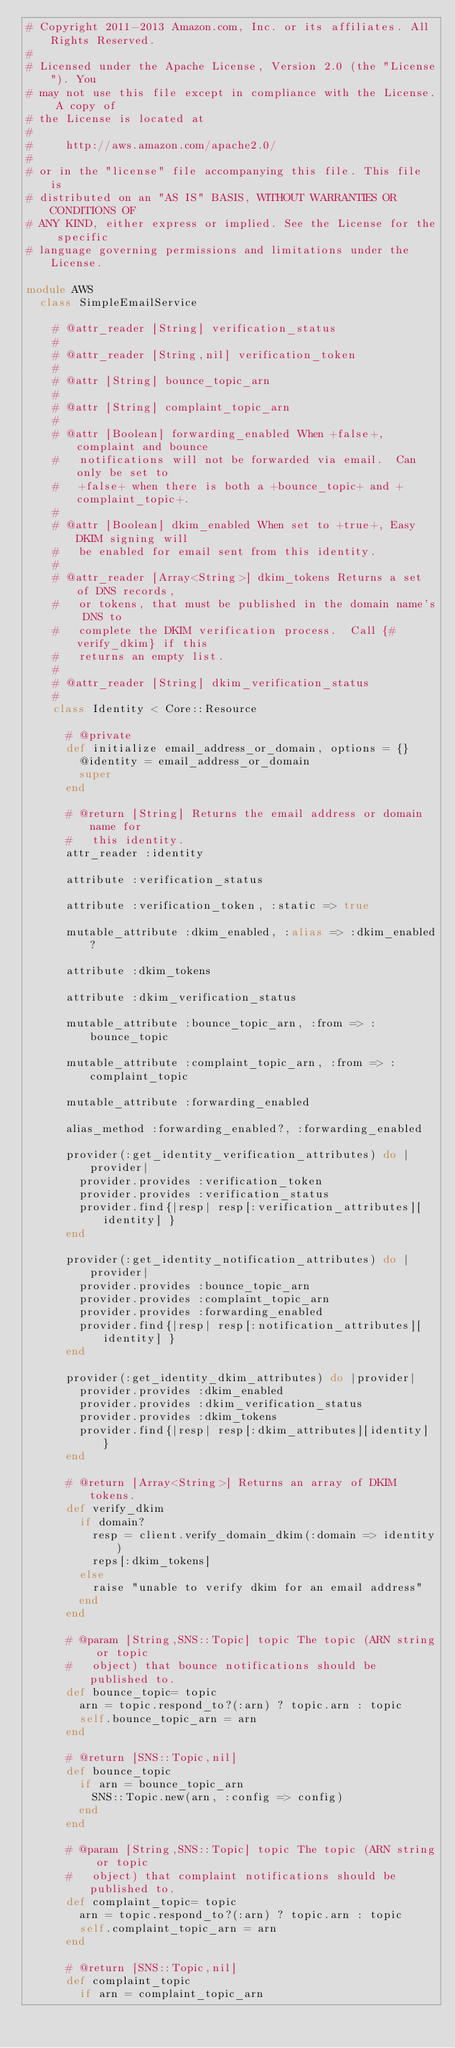<code> <loc_0><loc_0><loc_500><loc_500><_Ruby_># Copyright 2011-2013 Amazon.com, Inc. or its affiliates. All Rights Reserved.
#
# Licensed under the Apache License, Version 2.0 (the "License"). You
# may not use this file except in compliance with the License. A copy of
# the License is located at
#
#     http://aws.amazon.com/apache2.0/
#
# or in the "license" file accompanying this file. This file is
# distributed on an "AS IS" BASIS, WITHOUT WARRANTIES OR CONDITIONS OF
# ANY KIND, either express or implied. See the License for the specific
# language governing permissions and limitations under the License.

module AWS
  class SimpleEmailService

    # @attr_reader [String] verification_status
    #
    # @attr_reader [String,nil] verification_token
    #
    # @attr [String] bounce_topic_arn
    #
    # @attr [String] complaint_topic_arn
    #
    # @attr [Boolean] forwarding_enabled When +false+, complaint and bounce
    #   notifications will not be forwarded via email.  Can only be set to
    #   +false+ when there is both a +bounce_topic+ and +complaint_topic+.
    #
    # @attr [Boolean] dkim_enabled When set to +true+, Easy DKIM signing will
    #   be enabled for email sent from this identity.
    #
    # @attr_reader [Array<String>] dkim_tokens Returns a set of DNS records,
    #   or tokens, that must be published in the domain name's DNS to 
    #   complete the DKIM verification process.  Call {#verify_dkim} if this
    #   returns an empty list.
    #
    # @attr_reader [String] dkim_verification_status
    #
    class Identity < Core::Resource

      # @private
      def initialize email_address_or_domain, options = {}
        @identity = email_address_or_domain
        super
      end

      # @return [String] Returns the email address or domain name for
      #   this identity.
      attr_reader :identity

      attribute :verification_status

      attribute :verification_token, :static => true

      mutable_attribute :dkim_enabled, :alias => :dkim_enabled?

      attribute :dkim_tokens

      attribute :dkim_verification_status

      mutable_attribute :bounce_topic_arn, :from => :bounce_topic

      mutable_attribute :complaint_topic_arn, :from => :complaint_topic

      mutable_attribute :forwarding_enabled

      alias_method :forwarding_enabled?, :forwarding_enabled

      provider(:get_identity_verification_attributes) do |provider|
        provider.provides :verification_token
        provider.provides :verification_status
        provider.find{|resp| resp[:verification_attributes][identity] }
      end

      provider(:get_identity_notification_attributes) do |provider|
        provider.provides :bounce_topic_arn
        provider.provides :complaint_topic_arn
        provider.provides :forwarding_enabled
        provider.find{|resp| resp[:notification_attributes][identity] }
      end

      provider(:get_identity_dkim_attributes) do |provider|
        provider.provides :dkim_enabled
        provider.provides :dkim_verification_status
        provider.provides :dkim_tokens
        provider.find{|resp| resp[:dkim_attributes][identity] }
      end

      # @return [Array<String>] Returns an array of DKIM tokens.
      def verify_dkim
        if domain?
          resp = client.verify_domain_dkim(:domain => identity)
          reps[:dkim_tokens]
        else
          raise "unable to verify dkim for an email address"
        end
      end

      # @param [String,SNS::Topic] topic The topic (ARN string or topic
      #   object) that bounce notifications should be published to.
      def bounce_topic= topic
        arn = topic.respond_to?(:arn) ? topic.arn : topic
        self.bounce_topic_arn = arn
      end

      # @return [SNS::Topic,nil]
      def bounce_topic
        if arn = bounce_topic_arn
          SNS::Topic.new(arn, :config => config)
        end
      end

      # @param [String,SNS::Topic] topic The topic (ARN string or topic
      #   object) that complaint notifications should be published to.
      def complaint_topic= topic
        arn = topic.respond_to?(:arn) ? topic.arn : topic
        self.complaint_topic_arn = arn
      end

      # @return [SNS::Topic,nil]
      def complaint_topic
        if arn = complaint_topic_arn</code> 